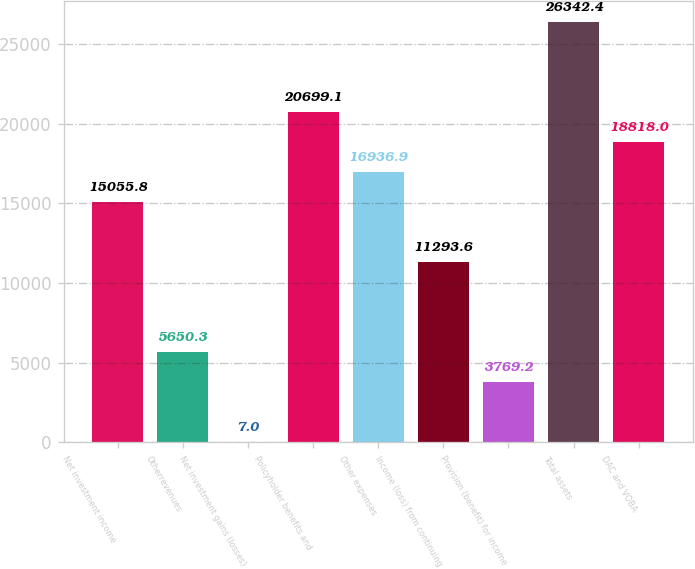<chart> <loc_0><loc_0><loc_500><loc_500><bar_chart><fcel>Net investment income<fcel>Otherrevenues<fcel>Net investment gains (losses)<fcel>Policyholder benefits and<fcel>Other expenses<fcel>Income (loss) from continuing<fcel>Provision (benefit) for income<fcel>Total assets<fcel>DAC and VOBA<nl><fcel>15055.8<fcel>5650.3<fcel>7<fcel>20699.1<fcel>16936.9<fcel>11293.6<fcel>3769.2<fcel>26342.4<fcel>18818<nl></chart> 